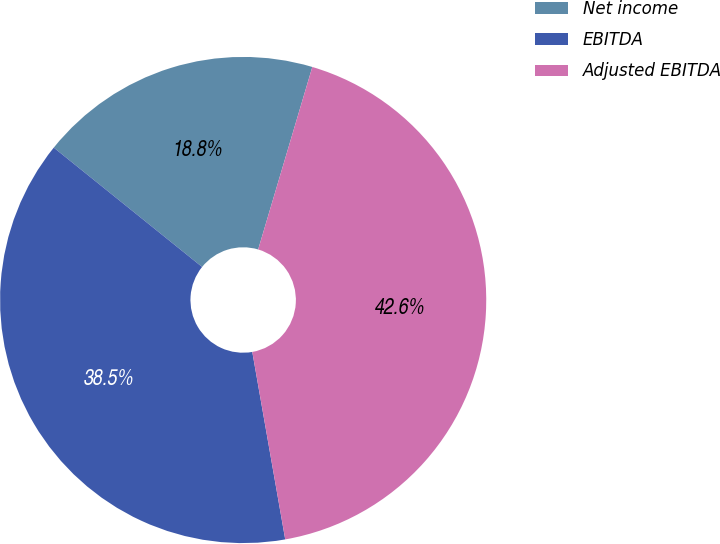Convert chart. <chart><loc_0><loc_0><loc_500><loc_500><pie_chart><fcel>Net income<fcel>EBITDA<fcel>Adjusted EBITDA<nl><fcel>18.81%<fcel>38.55%<fcel>42.64%<nl></chart> 